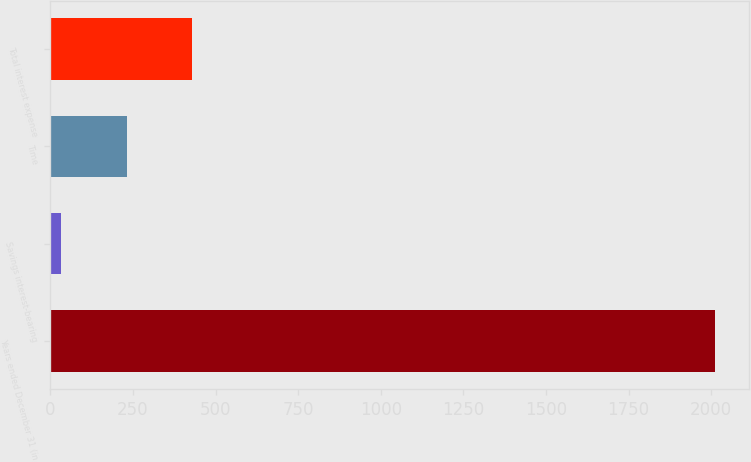Convert chart to OTSL. <chart><loc_0><loc_0><loc_500><loc_500><bar_chart><fcel>Years ended December 31 (in<fcel>Savings interest-bearing<fcel>Time<fcel>Total interest expense<nl><fcel>2013<fcel>33<fcel>231<fcel>429<nl></chart> 